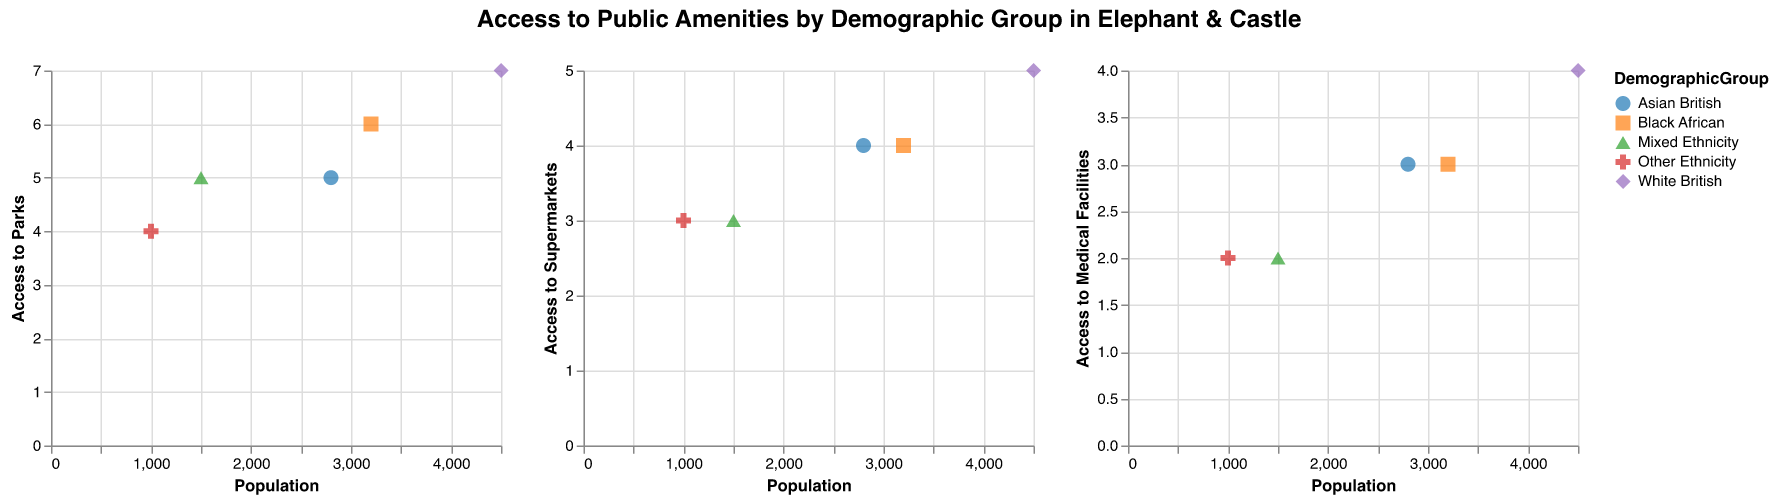What is the title of the figure? The title is located at the top of the figure, indicating the overall topic of the visualization.
Answer: Access to Public Amenities by Demographic Group in Elephant & Castle Which demographic group has the highest population? The scatter plot shows the populations of different demographic groups. The point with the highest x-axis value represents the highest population.
Answer: White British How many demographic groups have the same level of access to supermarkets? By inspecting the y-axis of the scatter plot titled "Access to Supermarkets," identify the points that share the same y-value.
Answer: Two demographic groups (Asian British and Black African) What is the range of access to parks across all demographic groups? Identify the lowest and highest y-values in the "Access to Parks" subplot, then calculate the difference.
Answer: 4 to 7 Which demographic group has the least access to medical facilities? Check the scatter plot titled "Access to Medical Facilities" for the point with the lowest y-axis value.
Answer: Other Ethnicity Compare the access to parks for White British and Mixed Ethnicity groups. Which one has better access? Look at the y-values corresponding to these two groups in the "Access to Parks" subplot. White British has a y-value of 7, and Mixed Ethnicity has a y-value of 5.
Answer: White British What is the average access to parks for the four demographic groups: Black African, Asian British, Mixed Ethnicity, and Other Ethnicity? Sum their access to parks values: 6+5+5+4 = 20. Divide by the number of groups: 20/4.
Answer: 5 By how much does access to supermarkets for White British exceed access to supermarkets of Mixed Ethnicity? Subtract the y-value for Mixed Ethnicity (3) from that for White British (5) in the "Access to Supermarkets" subplot.
Answer: 2 Does any demographic group show equal access to all three types of public amenities? Check if any point in each subplot coincides in y-values across the "Access to Parks," "Access to Supermarkets," and "Access to Medical Facilities" subplots.
Answer: No In which category do we observe the smallest variation among demographic groups' access levels? Compare the ranges of y-values in each subplot. The "Access to Medical Facilities" subplot varies between 2 and 4. The other two subplots show wider ranges.
Answer: Access to Medical Facilities 